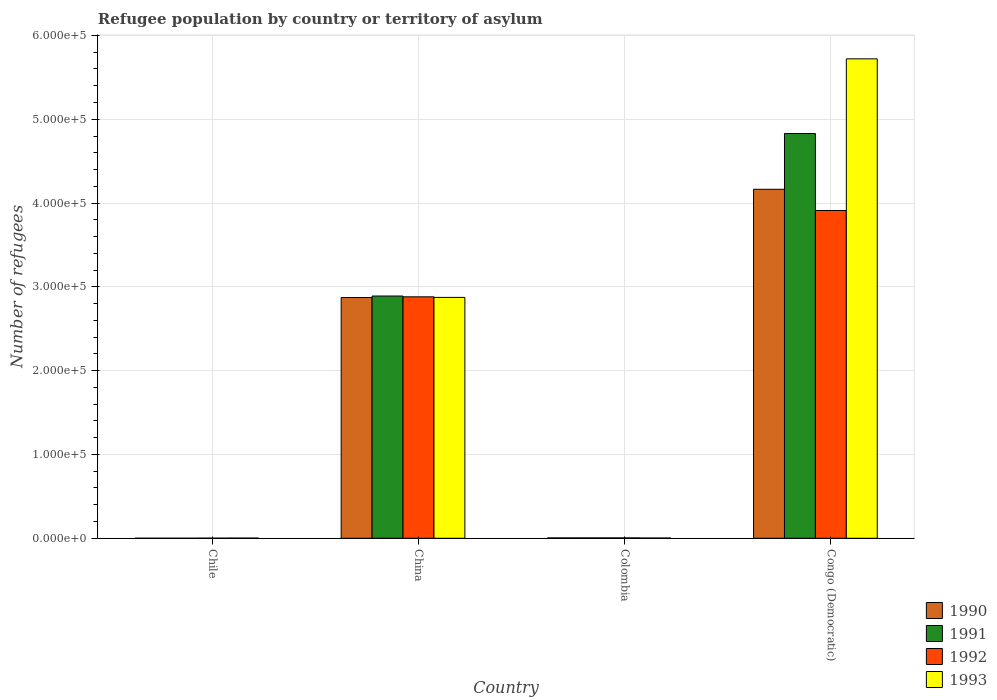How many groups of bars are there?
Keep it short and to the point. 4. Are the number of bars per tick equal to the number of legend labels?
Your answer should be compact. Yes. What is the label of the 2nd group of bars from the left?
Ensure brevity in your answer.  China. What is the number of refugees in 1991 in Congo (Democratic)?
Provide a succinct answer. 4.83e+05. Across all countries, what is the maximum number of refugees in 1990?
Your response must be concise. 4.16e+05. Across all countries, what is the minimum number of refugees in 1993?
Offer a terse response. 239. In which country was the number of refugees in 1991 maximum?
Your answer should be very brief. Congo (Democratic). What is the total number of refugees in 1993 in the graph?
Offer a terse response. 8.60e+05. What is the difference between the number of refugees in 1993 in China and that in Colombia?
Give a very brief answer. 2.87e+05. What is the difference between the number of refugees in 1993 in Colombia and the number of refugees in 1991 in Congo (Democratic)?
Your answer should be compact. -4.83e+05. What is the average number of refugees in 1992 per country?
Make the answer very short. 1.70e+05. In how many countries, is the number of refugees in 1991 greater than 580000?
Your answer should be very brief. 0. What is the ratio of the number of refugees in 1993 in Chile to that in China?
Your response must be concise. 0. Is the difference between the number of refugees in 1990 in Chile and Congo (Democratic) greater than the difference between the number of refugees in 1992 in Chile and Congo (Democratic)?
Keep it short and to the point. No. What is the difference between the highest and the second highest number of refugees in 1990?
Provide a short and direct response. -4.16e+05. What is the difference between the highest and the lowest number of refugees in 1992?
Keep it short and to the point. 3.91e+05. In how many countries, is the number of refugees in 1991 greater than the average number of refugees in 1991 taken over all countries?
Provide a succinct answer. 2. How many bars are there?
Offer a very short reply. 16. Are all the bars in the graph horizontal?
Ensure brevity in your answer.  No. Where does the legend appear in the graph?
Make the answer very short. Bottom right. How many legend labels are there?
Offer a terse response. 4. How are the legend labels stacked?
Make the answer very short. Vertical. What is the title of the graph?
Ensure brevity in your answer.  Refugee population by country or territory of asylum. What is the label or title of the Y-axis?
Make the answer very short. Number of refugees. What is the Number of refugees in 1990 in Chile?
Your answer should be compact. 58. What is the Number of refugees of 1992 in Chile?
Your answer should be compact. 142. What is the Number of refugees of 1993 in Chile?
Keep it short and to the point. 239. What is the Number of refugees in 1990 in China?
Your response must be concise. 2.87e+05. What is the Number of refugees in 1991 in China?
Provide a short and direct response. 2.89e+05. What is the Number of refugees in 1992 in China?
Your answer should be very brief. 2.88e+05. What is the Number of refugees of 1993 in China?
Ensure brevity in your answer.  2.87e+05. What is the Number of refugees in 1990 in Colombia?
Keep it short and to the point. 460. What is the Number of refugees of 1991 in Colombia?
Ensure brevity in your answer.  450. What is the Number of refugees in 1992 in Colombia?
Your response must be concise. 478. What is the Number of refugees in 1993 in Colombia?
Make the answer very short. 298. What is the Number of refugees in 1990 in Congo (Democratic)?
Offer a terse response. 4.16e+05. What is the Number of refugees in 1991 in Congo (Democratic)?
Give a very brief answer. 4.83e+05. What is the Number of refugees of 1992 in Congo (Democratic)?
Make the answer very short. 3.91e+05. What is the Number of refugees of 1993 in Congo (Democratic)?
Make the answer very short. 5.72e+05. Across all countries, what is the maximum Number of refugees in 1990?
Your response must be concise. 4.16e+05. Across all countries, what is the maximum Number of refugees in 1991?
Your answer should be very brief. 4.83e+05. Across all countries, what is the maximum Number of refugees of 1992?
Offer a very short reply. 3.91e+05. Across all countries, what is the maximum Number of refugees in 1993?
Offer a terse response. 5.72e+05. Across all countries, what is the minimum Number of refugees in 1990?
Give a very brief answer. 58. Across all countries, what is the minimum Number of refugees of 1991?
Your answer should be very brief. 72. Across all countries, what is the minimum Number of refugees in 1992?
Give a very brief answer. 142. Across all countries, what is the minimum Number of refugees of 1993?
Keep it short and to the point. 239. What is the total Number of refugees in 1990 in the graph?
Make the answer very short. 7.04e+05. What is the total Number of refugees in 1991 in the graph?
Ensure brevity in your answer.  7.73e+05. What is the total Number of refugees in 1992 in the graph?
Make the answer very short. 6.80e+05. What is the total Number of refugees in 1993 in the graph?
Your answer should be compact. 8.60e+05. What is the difference between the Number of refugees in 1990 in Chile and that in China?
Give a very brief answer. -2.87e+05. What is the difference between the Number of refugees in 1991 in Chile and that in China?
Your response must be concise. -2.89e+05. What is the difference between the Number of refugees of 1992 in Chile and that in China?
Offer a very short reply. -2.88e+05. What is the difference between the Number of refugees of 1993 in Chile and that in China?
Your response must be concise. -2.87e+05. What is the difference between the Number of refugees of 1990 in Chile and that in Colombia?
Your answer should be compact. -402. What is the difference between the Number of refugees of 1991 in Chile and that in Colombia?
Provide a short and direct response. -378. What is the difference between the Number of refugees in 1992 in Chile and that in Colombia?
Make the answer very short. -336. What is the difference between the Number of refugees of 1993 in Chile and that in Colombia?
Provide a short and direct response. -59. What is the difference between the Number of refugees in 1990 in Chile and that in Congo (Democratic)?
Make the answer very short. -4.16e+05. What is the difference between the Number of refugees in 1991 in Chile and that in Congo (Democratic)?
Provide a succinct answer. -4.83e+05. What is the difference between the Number of refugees of 1992 in Chile and that in Congo (Democratic)?
Make the answer very short. -3.91e+05. What is the difference between the Number of refugees in 1993 in Chile and that in Congo (Democratic)?
Make the answer very short. -5.72e+05. What is the difference between the Number of refugees in 1990 in China and that in Colombia?
Offer a very short reply. 2.87e+05. What is the difference between the Number of refugees in 1991 in China and that in Colombia?
Your answer should be very brief. 2.89e+05. What is the difference between the Number of refugees in 1992 in China and that in Colombia?
Offer a terse response. 2.88e+05. What is the difference between the Number of refugees of 1993 in China and that in Colombia?
Your answer should be very brief. 2.87e+05. What is the difference between the Number of refugees in 1990 in China and that in Congo (Democratic)?
Offer a terse response. -1.29e+05. What is the difference between the Number of refugees of 1991 in China and that in Congo (Democratic)?
Your answer should be compact. -1.94e+05. What is the difference between the Number of refugees in 1992 in China and that in Congo (Democratic)?
Provide a short and direct response. -1.03e+05. What is the difference between the Number of refugees of 1993 in China and that in Congo (Democratic)?
Make the answer very short. -2.85e+05. What is the difference between the Number of refugees of 1990 in Colombia and that in Congo (Democratic)?
Ensure brevity in your answer.  -4.16e+05. What is the difference between the Number of refugees in 1991 in Colombia and that in Congo (Democratic)?
Give a very brief answer. -4.83e+05. What is the difference between the Number of refugees in 1992 in Colombia and that in Congo (Democratic)?
Provide a short and direct response. -3.91e+05. What is the difference between the Number of refugees of 1993 in Colombia and that in Congo (Democratic)?
Offer a terse response. -5.72e+05. What is the difference between the Number of refugees of 1990 in Chile and the Number of refugees of 1991 in China?
Offer a very short reply. -2.89e+05. What is the difference between the Number of refugees in 1990 in Chile and the Number of refugees in 1992 in China?
Your response must be concise. -2.88e+05. What is the difference between the Number of refugees of 1990 in Chile and the Number of refugees of 1993 in China?
Your answer should be compact. -2.87e+05. What is the difference between the Number of refugees in 1991 in Chile and the Number of refugees in 1992 in China?
Offer a terse response. -2.88e+05. What is the difference between the Number of refugees of 1991 in Chile and the Number of refugees of 1993 in China?
Keep it short and to the point. -2.87e+05. What is the difference between the Number of refugees of 1992 in Chile and the Number of refugees of 1993 in China?
Provide a short and direct response. -2.87e+05. What is the difference between the Number of refugees in 1990 in Chile and the Number of refugees in 1991 in Colombia?
Give a very brief answer. -392. What is the difference between the Number of refugees in 1990 in Chile and the Number of refugees in 1992 in Colombia?
Keep it short and to the point. -420. What is the difference between the Number of refugees of 1990 in Chile and the Number of refugees of 1993 in Colombia?
Offer a very short reply. -240. What is the difference between the Number of refugees in 1991 in Chile and the Number of refugees in 1992 in Colombia?
Your answer should be very brief. -406. What is the difference between the Number of refugees in 1991 in Chile and the Number of refugees in 1993 in Colombia?
Your answer should be compact. -226. What is the difference between the Number of refugees of 1992 in Chile and the Number of refugees of 1993 in Colombia?
Ensure brevity in your answer.  -156. What is the difference between the Number of refugees in 1990 in Chile and the Number of refugees in 1991 in Congo (Democratic)?
Your answer should be very brief. -4.83e+05. What is the difference between the Number of refugees of 1990 in Chile and the Number of refugees of 1992 in Congo (Democratic)?
Offer a terse response. -3.91e+05. What is the difference between the Number of refugees in 1990 in Chile and the Number of refugees in 1993 in Congo (Democratic)?
Keep it short and to the point. -5.72e+05. What is the difference between the Number of refugees of 1991 in Chile and the Number of refugees of 1992 in Congo (Democratic)?
Make the answer very short. -3.91e+05. What is the difference between the Number of refugees in 1991 in Chile and the Number of refugees in 1993 in Congo (Democratic)?
Your answer should be very brief. -5.72e+05. What is the difference between the Number of refugees in 1992 in Chile and the Number of refugees in 1993 in Congo (Democratic)?
Offer a very short reply. -5.72e+05. What is the difference between the Number of refugees of 1990 in China and the Number of refugees of 1991 in Colombia?
Ensure brevity in your answer.  2.87e+05. What is the difference between the Number of refugees of 1990 in China and the Number of refugees of 1992 in Colombia?
Your answer should be compact. 2.87e+05. What is the difference between the Number of refugees of 1990 in China and the Number of refugees of 1993 in Colombia?
Your response must be concise. 2.87e+05. What is the difference between the Number of refugees in 1991 in China and the Number of refugees in 1992 in Colombia?
Offer a very short reply. 2.89e+05. What is the difference between the Number of refugees of 1991 in China and the Number of refugees of 1993 in Colombia?
Offer a very short reply. 2.89e+05. What is the difference between the Number of refugees in 1992 in China and the Number of refugees in 1993 in Colombia?
Your answer should be very brief. 2.88e+05. What is the difference between the Number of refugees in 1990 in China and the Number of refugees in 1991 in Congo (Democratic)?
Give a very brief answer. -1.96e+05. What is the difference between the Number of refugees in 1990 in China and the Number of refugees in 1992 in Congo (Democratic)?
Your answer should be compact. -1.04e+05. What is the difference between the Number of refugees in 1990 in China and the Number of refugees in 1993 in Congo (Democratic)?
Your response must be concise. -2.85e+05. What is the difference between the Number of refugees of 1991 in China and the Number of refugees of 1992 in Congo (Democratic)?
Ensure brevity in your answer.  -1.02e+05. What is the difference between the Number of refugees in 1991 in China and the Number of refugees in 1993 in Congo (Democratic)?
Provide a short and direct response. -2.83e+05. What is the difference between the Number of refugees of 1992 in China and the Number of refugees of 1993 in Congo (Democratic)?
Keep it short and to the point. -2.84e+05. What is the difference between the Number of refugees in 1990 in Colombia and the Number of refugees in 1991 in Congo (Democratic)?
Provide a short and direct response. -4.82e+05. What is the difference between the Number of refugees in 1990 in Colombia and the Number of refugees in 1992 in Congo (Democratic)?
Your response must be concise. -3.91e+05. What is the difference between the Number of refugees of 1990 in Colombia and the Number of refugees of 1993 in Congo (Democratic)?
Your response must be concise. -5.72e+05. What is the difference between the Number of refugees of 1991 in Colombia and the Number of refugees of 1992 in Congo (Democratic)?
Ensure brevity in your answer.  -3.91e+05. What is the difference between the Number of refugees of 1991 in Colombia and the Number of refugees of 1993 in Congo (Democratic)?
Give a very brief answer. -5.72e+05. What is the difference between the Number of refugees of 1992 in Colombia and the Number of refugees of 1993 in Congo (Democratic)?
Your answer should be compact. -5.72e+05. What is the average Number of refugees in 1990 per country?
Your answer should be very brief. 1.76e+05. What is the average Number of refugees of 1991 per country?
Keep it short and to the point. 1.93e+05. What is the average Number of refugees in 1992 per country?
Keep it short and to the point. 1.70e+05. What is the average Number of refugees in 1993 per country?
Provide a succinct answer. 2.15e+05. What is the difference between the Number of refugees in 1990 and Number of refugees in 1992 in Chile?
Your answer should be compact. -84. What is the difference between the Number of refugees of 1990 and Number of refugees of 1993 in Chile?
Your response must be concise. -181. What is the difference between the Number of refugees of 1991 and Number of refugees of 1992 in Chile?
Give a very brief answer. -70. What is the difference between the Number of refugees in 1991 and Number of refugees in 1993 in Chile?
Your response must be concise. -167. What is the difference between the Number of refugees of 1992 and Number of refugees of 1993 in Chile?
Your response must be concise. -97. What is the difference between the Number of refugees in 1990 and Number of refugees in 1991 in China?
Keep it short and to the point. -1785. What is the difference between the Number of refugees in 1990 and Number of refugees in 1992 in China?
Make the answer very short. -847. What is the difference between the Number of refugees of 1990 and Number of refugees of 1993 in China?
Make the answer very short. -147. What is the difference between the Number of refugees of 1991 and Number of refugees of 1992 in China?
Make the answer very short. 938. What is the difference between the Number of refugees in 1991 and Number of refugees in 1993 in China?
Offer a very short reply. 1638. What is the difference between the Number of refugees of 1992 and Number of refugees of 1993 in China?
Offer a very short reply. 700. What is the difference between the Number of refugees of 1990 and Number of refugees of 1992 in Colombia?
Give a very brief answer. -18. What is the difference between the Number of refugees in 1990 and Number of refugees in 1993 in Colombia?
Offer a very short reply. 162. What is the difference between the Number of refugees of 1991 and Number of refugees of 1992 in Colombia?
Give a very brief answer. -28. What is the difference between the Number of refugees of 1991 and Number of refugees of 1993 in Colombia?
Make the answer very short. 152. What is the difference between the Number of refugees of 1992 and Number of refugees of 1993 in Colombia?
Offer a very short reply. 180. What is the difference between the Number of refugees in 1990 and Number of refugees in 1991 in Congo (Democratic)?
Your answer should be compact. -6.65e+04. What is the difference between the Number of refugees of 1990 and Number of refugees of 1992 in Congo (Democratic)?
Make the answer very short. 2.53e+04. What is the difference between the Number of refugees of 1990 and Number of refugees of 1993 in Congo (Democratic)?
Offer a very short reply. -1.56e+05. What is the difference between the Number of refugees of 1991 and Number of refugees of 1992 in Congo (Democratic)?
Ensure brevity in your answer.  9.18e+04. What is the difference between the Number of refugees in 1991 and Number of refugees in 1993 in Congo (Democratic)?
Offer a terse response. -8.91e+04. What is the difference between the Number of refugees in 1992 and Number of refugees in 1993 in Congo (Democratic)?
Make the answer very short. -1.81e+05. What is the ratio of the Number of refugees of 1992 in Chile to that in China?
Offer a terse response. 0. What is the ratio of the Number of refugees of 1993 in Chile to that in China?
Make the answer very short. 0. What is the ratio of the Number of refugees in 1990 in Chile to that in Colombia?
Provide a short and direct response. 0.13. What is the ratio of the Number of refugees of 1991 in Chile to that in Colombia?
Keep it short and to the point. 0.16. What is the ratio of the Number of refugees in 1992 in Chile to that in Colombia?
Provide a succinct answer. 0.3. What is the ratio of the Number of refugees in 1993 in Chile to that in Colombia?
Provide a succinct answer. 0.8. What is the ratio of the Number of refugees of 1990 in Chile to that in Congo (Democratic)?
Give a very brief answer. 0. What is the ratio of the Number of refugees in 1990 in China to that in Colombia?
Offer a terse response. 624.51. What is the ratio of the Number of refugees of 1991 in China to that in Colombia?
Your answer should be compact. 642.36. What is the ratio of the Number of refugees of 1992 in China to that in Colombia?
Make the answer very short. 602.77. What is the ratio of the Number of refugees in 1993 in China to that in Colombia?
Give a very brief answer. 964.51. What is the ratio of the Number of refugees in 1990 in China to that in Congo (Democratic)?
Make the answer very short. 0.69. What is the ratio of the Number of refugees in 1991 in China to that in Congo (Democratic)?
Your answer should be very brief. 0.6. What is the ratio of the Number of refugees of 1992 in China to that in Congo (Democratic)?
Keep it short and to the point. 0.74. What is the ratio of the Number of refugees of 1993 in China to that in Congo (Democratic)?
Provide a short and direct response. 0.5. What is the ratio of the Number of refugees of 1990 in Colombia to that in Congo (Democratic)?
Provide a short and direct response. 0. What is the ratio of the Number of refugees of 1991 in Colombia to that in Congo (Democratic)?
Ensure brevity in your answer.  0. What is the ratio of the Number of refugees of 1992 in Colombia to that in Congo (Democratic)?
Make the answer very short. 0. What is the difference between the highest and the second highest Number of refugees in 1990?
Your response must be concise. 1.29e+05. What is the difference between the highest and the second highest Number of refugees of 1991?
Give a very brief answer. 1.94e+05. What is the difference between the highest and the second highest Number of refugees of 1992?
Give a very brief answer. 1.03e+05. What is the difference between the highest and the second highest Number of refugees of 1993?
Your response must be concise. 2.85e+05. What is the difference between the highest and the lowest Number of refugees in 1990?
Make the answer very short. 4.16e+05. What is the difference between the highest and the lowest Number of refugees in 1991?
Your response must be concise. 4.83e+05. What is the difference between the highest and the lowest Number of refugees in 1992?
Make the answer very short. 3.91e+05. What is the difference between the highest and the lowest Number of refugees in 1993?
Offer a terse response. 5.72e+05. 